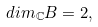<formula> <loc_0><loc_0><loc_500><loc_500>d i m _ { \mathbb { C } } B = 2 ,</formula> 